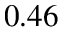<formula> <loc_0><loc_0><loc_500><loc_500>0 . 4 6</formula> 